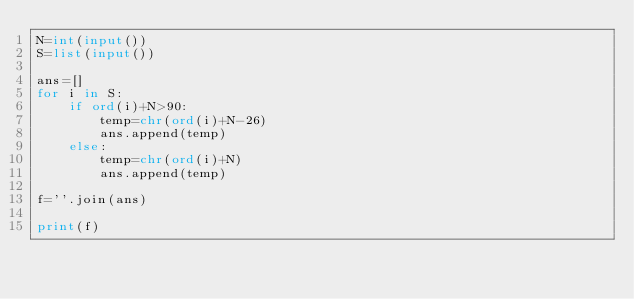Convert code to text. <code><loc_0><loc_0><loc_500><loc_500><_Python_>N=int(input())
S=list(input())
 
ans=[]
for i in S:
    if ord(i)+N>90:
        temp=chr(ord(i)+N-26)
        ans.append(temp)
    else:
        temp=chr(ord(i)+N)
        ans.append(temp)
 
f=''.join(ans)
 
print(f)</code> 